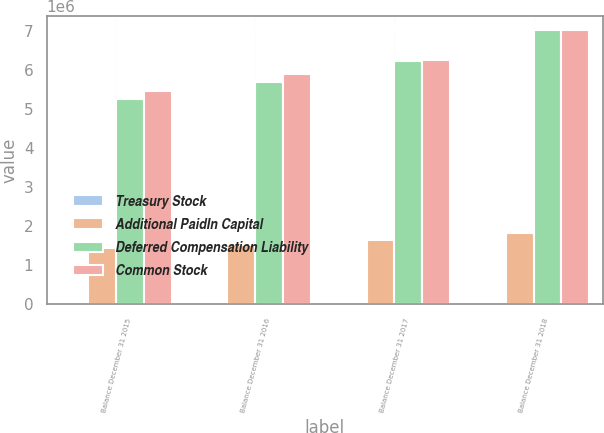Convert chart. <chart><loc_0><loc_0><loc_500><loc_500><stacked_bar_chart><ecel><fcel>Balance December 31 2015<fcel>Balance December 31 2016<fcel>Balance December 31 2017<fcel>Balance December 31 2018<nl><fcel>Treasury Stock<fcel>206<fcel>206<fcel>206<fcel>206<nl><fcel>Additional PaidIn Capital<fcel>1.4478e+06<fcel>1.51583e+06<fcel>1.6442e+06<fcel>1.82022e+06<nl><fcel>Deferred Compensation Liability<fcel>5.27011e+06<fcel>5.69538e+06<fcel>6.23194e+06<fcel>7.03133e+06<nl><fcel>Common Stock<fcel>5.47895e+06<fcel>5.90697e+06<fcel>6.27085e+06<fcel>7.0432e+06<nl></chart> 